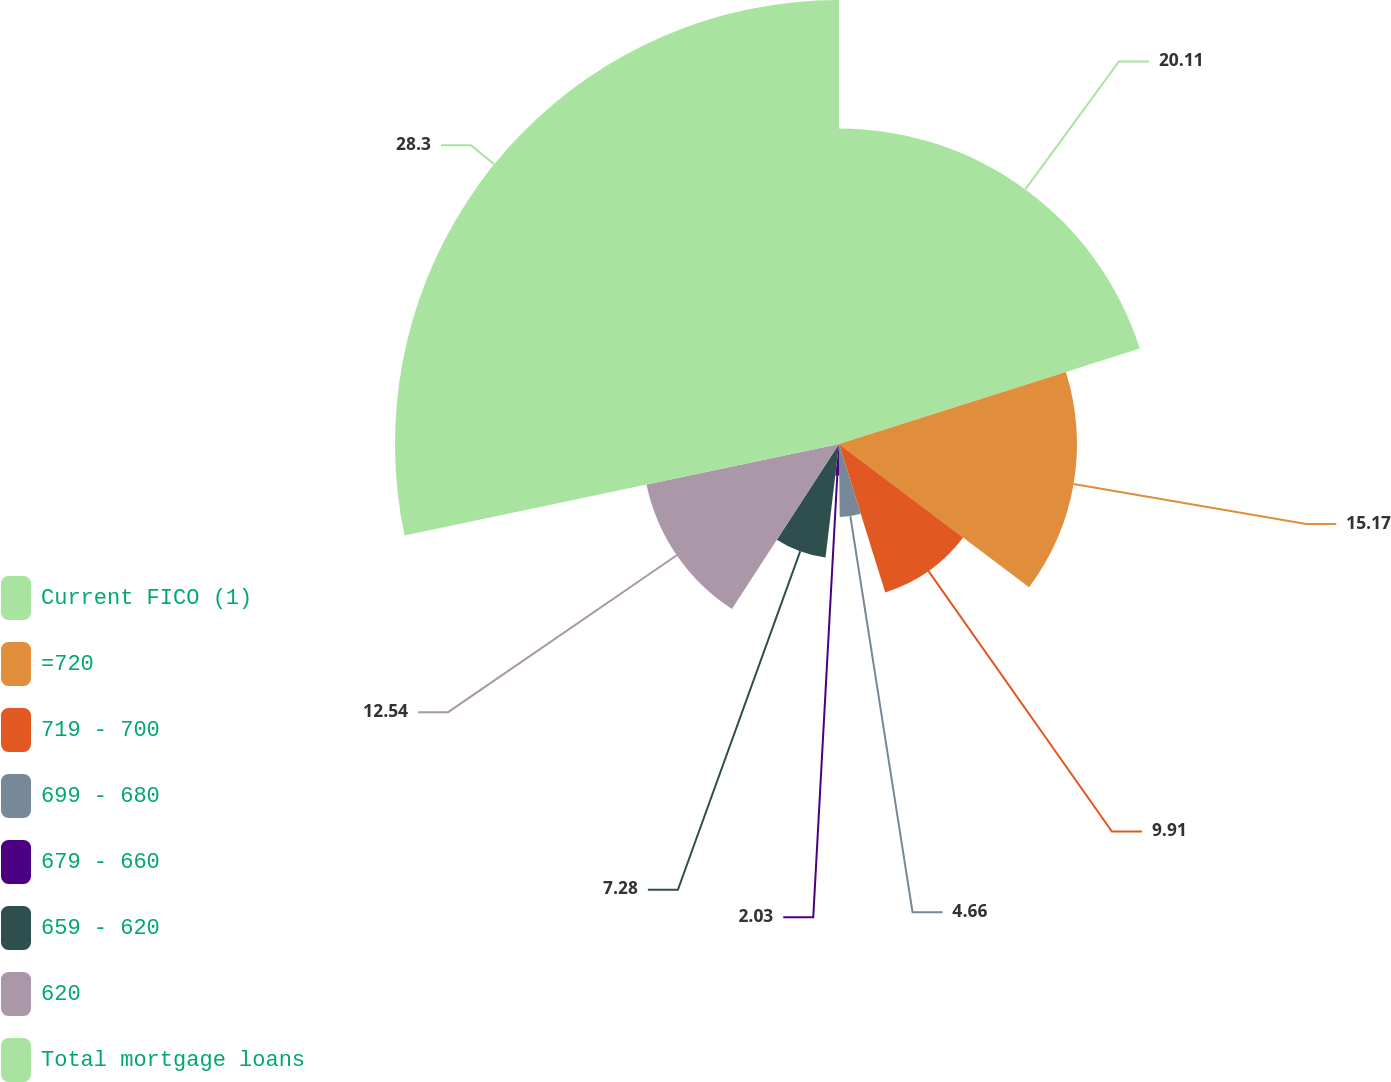Convert chart to OTSL. <chart><loc_0><loc_0><loc_500><loc_500><pie_chart><fcel>Current FICO (1)<fcel>=720<fcel>719 - 700<fcel>699 - 680<fcel>679 - 660<fcel>659 - 620<fcel>620<fcel>Total mortgage loans<nl><fcel>20.11%<fcel>15.17%<fcel>9.91%<fcel>4.66%<fcel>2.03%<fcel>7.28%<fcel>12.54%<fcel>28.3%<nl></chart> 